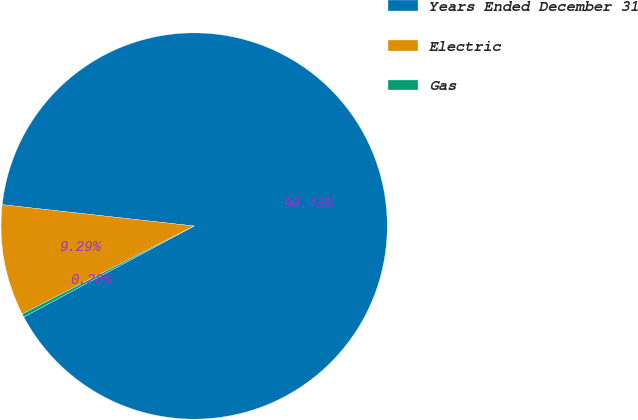<chart> <loc_0><loc_0><loc_500><loc_500><pie_chart><fcel>Years Ended December 31<fcel>Electric<fcel>Gas<nl><fcel>90.43%<fcel>9.29%<fcel>0.28%<nl></chart> 